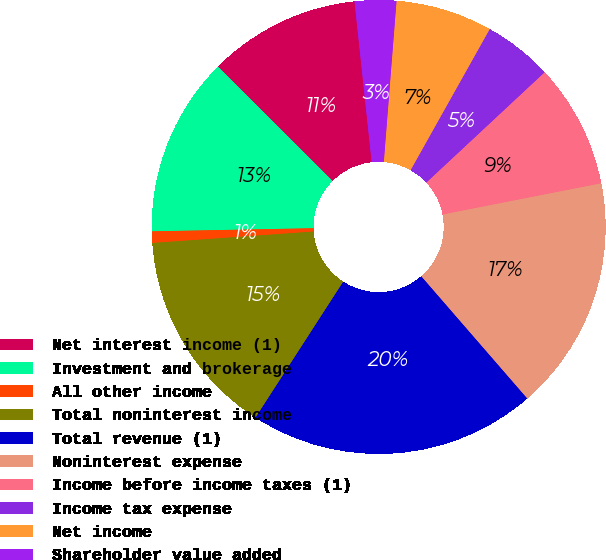<chart> <loc_0><loc_0><loc_500><loc_500><pie_chart><fcel>Net interest income (1)<fcel>Investment and brokerage<fcel>All other income<fcel>Total noninterest income<fcel>Total revenue (1)<fcel>Noninterest expense<fcel>Income before income taxes (1)<fcel>Income tax expense<fcel>Net income<fcel>Shareholder value added<nl><fcel>10.82%<fcel>12.79%<fcel>0.82%<fcel>14.75%<fcel>20.49%<fcel>16.72%<fcel>8.85%<fcel>4.92%<fcel>6.88%<fcel>2.95%<nl></chart> 